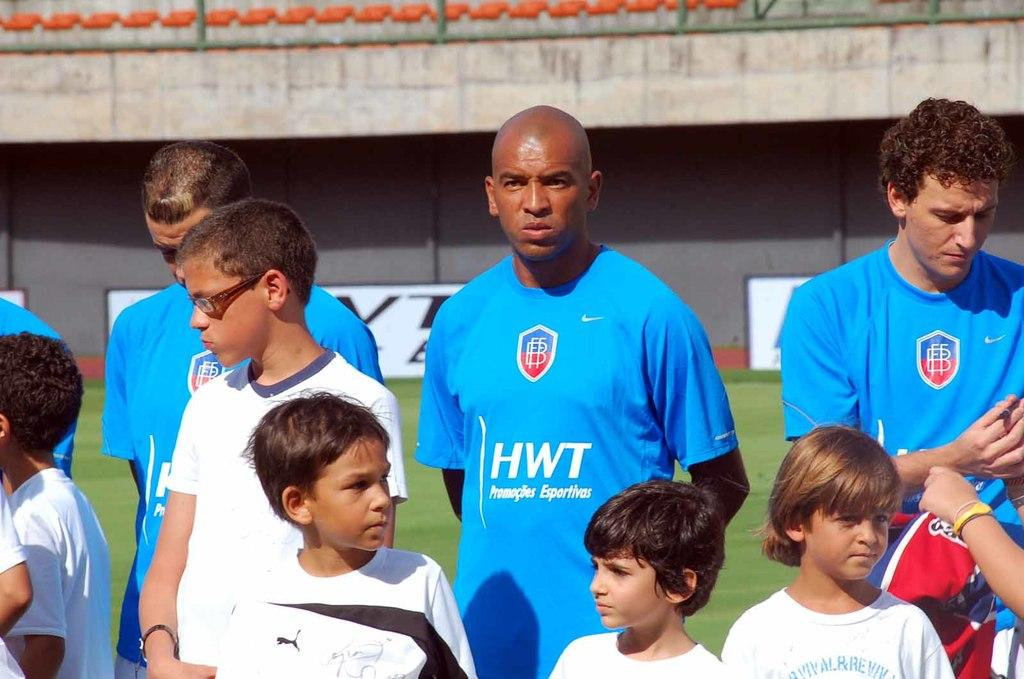<image>
Provide a brief description of the given image. Several soccer players standing on the field with the blue colored player having the hwt logo on his mid section. 